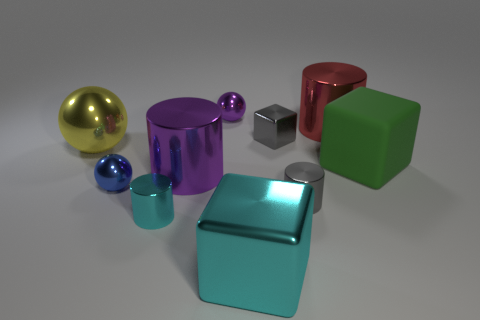What material is the large purple cylinder?
Your answer should be very brief. Metal. Are there more matte things in front of the gray metallic cylinder than green objects?
Keep it short and to the point. No. Is there a shiny cylinder?
Provide a succinct answer. Yes. What number of other objects are the same shape as the large red metallic thing?
Your answer should be very brief. 3. Is the color of the small ball behind the large green matte object the same as the metal cube behind the small cyan cylinder?
Give a very brief answer. No. There is a gray thing that is left of the gray object that is in front of the large cylinder that is in front of the big red thing; how big is it?
Provide a succinct answer. Small. The small metallic object that is to the right of the cyan cylinder and in front of the blue shiny ball has what shape?
Your answer should be compact. Cylinder. Are there the same number of purple cylinders to the right of the small cyan metal thing and tiny cyan objects behind the tiny purple ball?
Offer a terse response. No. Are there any small cylinders made of the same material as the red object?
Make the answer very short. Yes. Do the thing on the left side of the blue object and the big green cube have the same material?
Your response must be concise. No. 